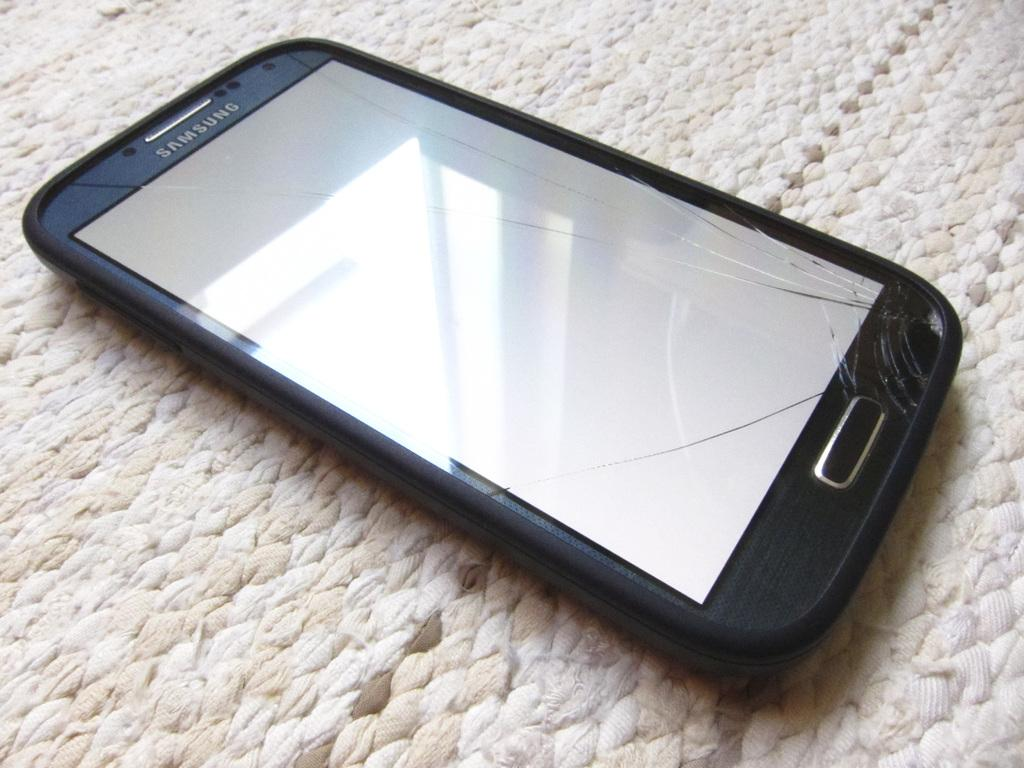<image>
Summarize the visual content of the image. A crack Samsung phone on a woven mat. 